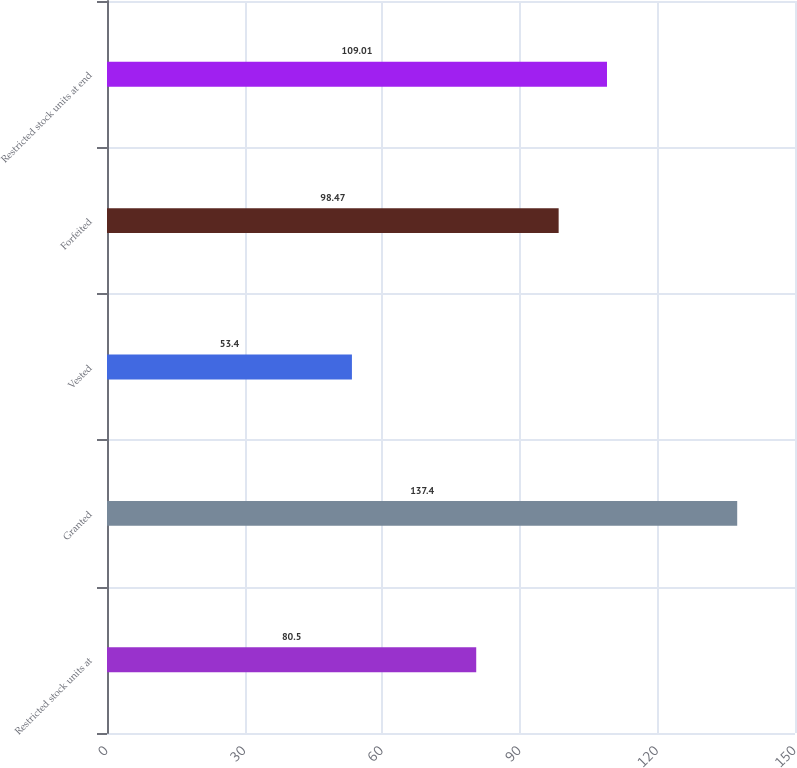Convert chart. <chart><loc_0><loc_0><loc_500><loc_500><bar_chart><fcel>Restricted stock units at<fcel>Granted<fcel>Vested<fcel>Forfeited<fcel>Restricted stock units at end<nl><fcel>80.5<fcel>137.4<fcel>53.4<fcel>98.47<fcel>109.01<nl></chart> 